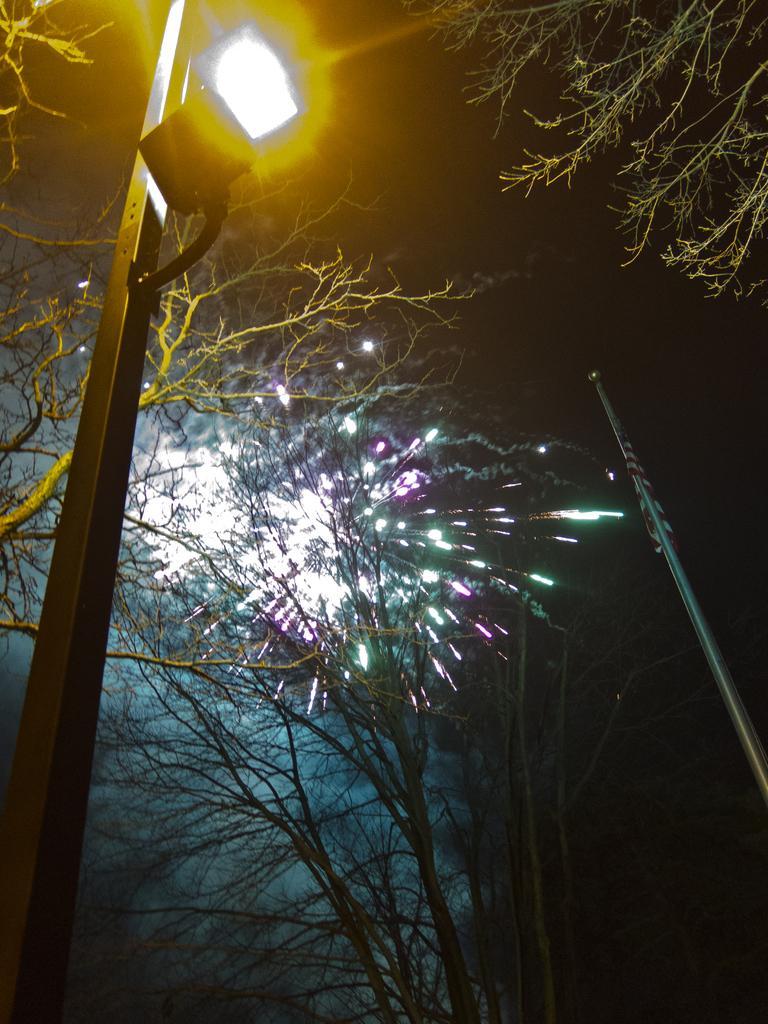Can you describe this image briefly? In this picture we can see trees and a street light. On the right side of the image, there is a flag to a pole. Behind the trees, there are fireworks. 